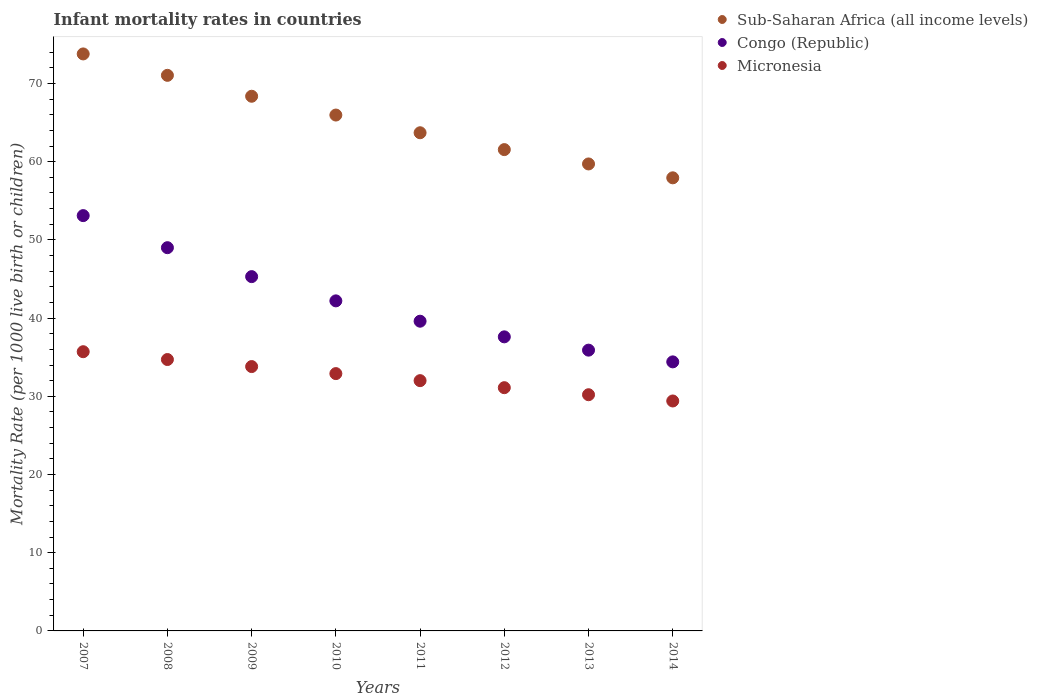Is the number of dotlines equal to the number of legend labels?
Make the answer very short. Yes. What is the infant mortality rate in Sub-Saharan Africa (all income levels) in 2012?
Provide a succinct answer. 61.54. Across all years, what is the maximum infant mortality rate in Sub-Saharan Africa (all income levels)?
Provide a succinct answer. 73.77. Across all years, what is the minimum infant mortality rate in Congo (Republic)?
Ensure brevity in your answer.  34.4. In which year was the infant mortality rate in Sub-Saharan Africa (all income levels) maximum?
Give a very brief answer. 2007. In which year was the infant mortality rate in Congo (Republic) minimum?
Your response must be concise. 2014. What is the total infant mortality rate in Sub-Saharan Africa (all income levels) in the graph?
Ensure brevity in your answer.  522. What is the difference between the infant mortality rate in Sub-Saharan Africa (all income levels) in 2011 and that in 2014?
Give a very brief answer. 5.76. What is the difference between the infant mortality rate in Sub-Saharan Africa (all income levels) in 2013 and the infant mortality rate in Congo (Republic) in 2012?
Make the answer very short. 22.11. What is the average infant mortality rate in Sub-Saharan Africa (all income levels) per year?
Offer a very short reply. 65.25. In the year 2009, what is the difference between the infant mortality rate in Sub-Saharan Africa (all income levels) and infant mortality rate in Micronesia?
Provide a short and direct response. 34.56. What is the ratio of the infant mortality rate in Sub-Saharan Africa (all income levels) in 2009 to that in 2014?
Make the answer very short. 1.18. Is the difference between the infant mortality rate in Sub-Saharan Africa (all income levels) in 2010 and 2013 greater than the difference between the infant mortality rate in Micronesia in 2010 and 2013?
Your answer should be compact. Yes. What is the difference between the highest and the second highest infant mortality rate in Micronesia?
Give a very brief answer. 1. What is the difference between the highest and the lowest infant mortality rate in Congo (Republic)?
Your answer should be very brief. 18.7. How many dotlines are there?
Offer a terse response. 3. Are the values on the major ticks of Y-axis written in scientific E-notation?
Provide a succinct answer. No. How are the legend labels stacked?
Your answer should be compact. Vertical. What is the title of the graph?
Your answer should be very brief. Infant mortality rates in countries. What is the label or title of the Y-axis?
Your response must be concise. Mortality Rate (per 1000 live birth or children). What is the Mortality Rate (per 1000 live birth or children) in Sub-Saharan Africa (all income levels) in 2007?
Your answer should be compact. 73.77. What is the Mortality Rate (per 1000 live birth or children) of Congo (Republic) in 2007?
Your answer should be compact. 53.1. What is the Mortality Rate (per 1000 live birth or children) of Micronesia in 2007?
Provide a short and direct response. 35.7. What is the Mortality Rate (per 1000 live birth or children) in Sub-Saharan Africa (all income levels) in 2008?
Keep it short and to the point. 71.04. What is the Mortality Rate (per 1000 live birth or children) in Micronesia in 2008?
Provide a succinct answer. 34.7. What is the Mortality Rate (per 1000 live birth or children) in Sub-Saharan Africa (all income levels) in 2009?
Offer a terse response. 68.36. What is the Mortality Rate (per 1000 live birth or children) in Congo (Republic) in 2009?
Your answer should be very brief. 45.3. What is the Mortality Rate (per 1000 live birth or children) of Micronesia in 2009?
Keep it short and to the point. 33.8. What is the Mortality Rate (per 1000 live birth or children) in Sub-Saharan Africa (all income levels) in 2010?
Offer a terse response. 65.96. What is the Mortality Rate (per 1000 live birth or children) of Congo (Republic) in 2010?
Keep it short and to the point. 42.2. What is the Mortality Rate (per 1000 live birth or children) in Micronesia in 2010?
Your response must be concise. 32.9. What is the Mortality Rate (per 1000 live birth or children) in Sub-Saharan Africa (all income levels) in 2011?
Your answer should be very brief. 63.7. What is the Mortality Rate (per 1000 live birth or children) in Congo (Republic) in 2011?
Provide a succinct answer. 39.6. What is the Mortality Rate (per 1000 live birth or children) in Micronesia in 2011?
Ensure brevity in your answer.  32. What is the Mortality Rate (per 1000 live birth or children) in Sub-Saharan Africa (all income levels) in 2012?
Your answer should be compact. 61.54. What is the Mortality Rate (per 1000 live birth or children) of Congo (Republic) in 2012?
Provide a succinct answer. 37.6. What is the Mortality Rate (per 1000 live birth or children) in Micronesia in 2012?
Ensure brevity in your answer.  31.1. What is the Mortality Rate (per 1000 live birth or children) of Sub-Saharan Africa (all income levels) in 2013?
Your answer should be compact. 59.71. What is the Mortality Rate (per 1000 live birth or children) in Congo (Republic) in 2013?
Your answer should be very brief. 35.9. What is the Mortality Rate (per 1000 live birth or children) of Micronesia in 2013?
Your answer should be compact. 30.2. What is the Mortality Rate (per 1000 live birth or children) of Sub-Saharan Africa (all income levels) in 2014?
Make the answer very short. 57.93. What is the Mortality Rate (per 1000 live birth or children) in Congo (Republic) in 2014?
Make the answer very short. 34.4. What is the Mortality Rate (per 1000 live birth or children) of Micronesia in 2014?
Your response must be concise. 29.4. Across all years, what is the maximum Mortality Rate (per 1000 live birth or children) in Sub-Saharan Africa (all income levels)?
Offer a terse response. 73.77. Across all years, what is the maximum Mortality Rate (per 1000 live birth or children) in Congo (Republic)?
Your answer should be very brief. 53.1. Across all years, what is the maximum Mortality Rate (per 1000 live birth or children) in Micronesia?
Provide a succinct answer. 35.7. Across all years, what is the minimum Mortality Rate (per 1000 live birth or children) in Sub-Saharan Africa (all income levels)?
Your answer should be compact. 57.93. Across all years, what is the minimum Mortality Rate (per 1000 live birth or children) in Congo (Republic)?
Your answer should be compact. 34.4. Across all years, what is the minimum Mortality Rate (per 1000 live birth or children) of Micronesia?
Your response must be concise. 29.4. What is the total Mortality Rate (per 1000 live birth or children) of Sub-Saharan Africa (all income levels) in the graph?
Keep it short and to the point. 522. What is the total Mortality Rate (per 1000 live birth or children) in Congo (Republic) in the graph?
Your answer should be compact. 337.1. What is the total Mortality Rate (per 1000 live birth or children) of Micronesia in the graph?
Offer a terse response. 259.8. What is the difference between the Mortality Rate (per 1000 live birth or children) of Sub-Saharan Africa (all income levels) in 2007 and that in 2008?
Provide a short and direct response. 2.74. What is the difference between the Mortality Rate (per 1000 live birth or children) of Sub-Saharan Africa (all income levels) in 2007 and that in 2009?
Provide a succinct answer. 5.41. What is the difference between the Mortality Rate (per 1000 live birth or children) in Congo (Republic) in 2007 and that in 2009?
Ensure brevity in your answer.  7.8. What is the difference between the Mortality Rate (per 1000 live birth or children) of Sub-Saharan Africa (all income levels) in 2007 and that in 2010?
Ensure brevity in your answer.  7.81. What is the difference between the Mortality Rate (per 1000 live birth or children) in Congo (Republic) in 2007 and that in 2010?
Provide a succinct answer. 10.9. What is the difference between the Mortality Rate (per 1000 live birth or children) of Sub-Saharan Africa (all income levels) in 2007 and that in 2011?
Provide a short and direct response. 10.08. What is the difference between the Mortality Rate (per 1000 live birth or children) of Congo (Republic) in 2007 and that in 2011?
Ensure brevity in your answer.  13.5. What is the difference between the Mortality Rate (per 1000 live birth or children) in Sub-Saharan Africa (all income levels) in 2007 and that in 2012?
Your answer should be very brief. 12.23. What is the difference between the Mortality Rate (per 1000 live birth or children) in Congo (Republic) in 2007 and that in 2012?
Your response must be concise. 15.5. What is the difference between the Mortality Rate (per 1000 live birth or children) of Sub-Saharan Africa (all income levels) in 2007 and that in 2013?
Provide a succinct answer. 14.07. What is the difference between the Mortality Rate (per 1000 live birth or children) in Congo (Republic) in 2007 and that in 2013?
Keep it short and to the point. 17.2. What is the difference between the Mortality Rate (per 1000 live birth or children) of Sub-Saharan Africa (all income levels) in 2007 and that in 2014?
Your answer should be very brief. 15.84. What is the difference between the Mortality Rate (per 1000 live birth or children) in Sub-Saharan Africa (all income levels) in 2008 and that in 2009?
Your response must be concise. 2.67. What is the difference between the Mortality Rate (per 1000 live birth or children) in Congo (Republic) in 2008 and that in 2009?
Give a very brief answer. 3.7. What is the difference between the Mortality Rate (per 1000 live birth or children) of Sub-Saharan Africa (all income levels) in 2008 and that in 2010?
Provide a succinct answer. 5.08. What is the difference between the Mortality Rate (per 1000 live birth or children) in Congo (Republic) in 2008 and that in 2010?
Provide a short and direct response. 6.8. What is the difference between the Mortality Rate (per 1000 live birth or children) in Micronesia in 2008 and that in 2010?
Your answer should be compact. 1.8. What is the difference between the Mortality Rate (per 1000 live birth or children) in Sub-Saharan Africa (all income levels) in 2008 and that in 2011?
Give a very brief answer. 7.34. What is the difference between the Mortality Rate (per 1000 live birth or children) in Congo (Republic) in 2008 and that in 2011?
Your answer should be compact. 9.4. What is the difference between the Mortality Rate (per 1000 live birth or children) in Sub-Saharan Africa (all income levels) in 2008 and that in 2012?
Make the answer very short. 9.5. What is the difference between the Mortality Rate (per 1000 live birth or children) in Sub-Saharan Africa (all income levels) in 2008 and that in 2013?
Provide a succinct answer. 11.33. What is the difference between the Mortality Rate (per 1000 live birth or children) of Micronesia in 2008 and that in 2013?
Your answer should be compact. 4.5. What is the difference between the Mortality Rate (per 1000 live birth or children) in Sub-Saharan Africa (all income levels) in 2008 and that in 2014?
Offer a terse response. 13.1. What is the difference between the Mortality Rate (per 1000 live birth or children) of Micronesia in 2008 and that in 2014?
Your response must be concise. 5.3. What is the difference between the Mortality Rate (per 1000 live birth or children) in Sub-Saharan Africa (all income levels) in 2009 and that in 2010?
Give a very brief answer. 2.4. What is the difference between the Mortality Rate (per 1000 live birth or children) in Congo (Republic) in 2009 and that in 2010?
Your answer should be compact. 3.1. What is the difference between the Mortality Rate (per 1000 live birth or children) in Sub-Saharan Africa (all income levels) in 2009 and that in 2011?
Offer a terse response. 4.67. What is the difference between the Mortality Rate (per 1000 live birth or children) in Congo (Republic) in 2009 and that in 2011?
Offer a very short reply. 5.7. What is the difference between the Mortality Rate (per 1000 live birth or children) in Micronesia in 2009 and that in 2011?
Offer a terse response. 1.8. What is the difference between the Mortality Rate (per 1000 live birth or children) of Sub-Saharan Africa (all income levels) in 2009 and that in 2012?
Ensure brevity in your answer.  6.82. What is the difference between the Mortality Rate (per 1000 live birth or children) in Congo (Republic) in 2009 and that in 2012?
Provide a succinct answer. 7.7. What is the difference between the Mortality Rate (per 1000 live birth or children) of Sub-Saharan Africa (all income levels) in 2009 and that in 2013?
Offer a very short reply. 8.65. What is the difference between the Mortality Rate (per 1000 live birth or children) in Congo (Republic) in 2009 and that in 2013?
Give a very brief answer. 9.4. What is the difference between the Mortality Rate (per 1000 live birth or children) in Micronesia in 2009 and that in 2013?
Give a very brief answer. 3.6. What is the difference between the Mortality Rate (per 1000 live birth or children) of Sub-Saharan Africa (all income levels) in 2009 and that in 2014?
Your answer should be compact. 10.43. What is the difference between the Mortality Rate (per 1000 live birth or children) in Congo (Republic) in 2009 and that in 2014?
Your response must be concise. 10.9. What is the difference between the Mortality Rate (per 1000 live birth or children) in Sub-Saharan Africa (all income levels) in 2010 and that in 2011?
Offer a terse response. 2.26. What is the difference between the Mortality Rate (per 1000 live birth or children) of Congo (Republic) in 2010 and that in 2011?
Offer a terse response. 2.6. What is the difference between the Mortality Rate (per 1000 live birth or children) of Sub-Saharan Africa (all income levels) in 2010 and that in 2012?
Provide a short and direct response. 4.42. What is the difference between the Mortality Rate (per 1000 live birth or children) of Micronesia in 2010 and that in 2012?
Your answer should be compact. 1.8. What is the difference between the Mortality Rate (per 1000 live birth or children) of Sub-Saharan Africa (all income levels) in 2010 and that in 2013?
Offer a very short reply. 6.25. What is the difference between the Mortality Rate (per 1000 live birth or children) in Micronesia in 2010 and that in 2013?
Provide a succinct answer. 2.7. What is the difference between the Mortality Rate (per 1000 live birth or children) in Sub-Saharan Africa (all income levels) in 2010 and that in 2014?
Provide a succinct answer. 8.03. What is the difference between the Mortality Rate (per 1000 live birth or children) of Sub-Saharan Africa (all income levels) in 2011 and that in 2012?
Ensure brevity in your answer.  2.15. What is the difference between the Mortality Rate (per 1000 live birth or children) in Congo (Republic) in 2011 and that in 2012?
Give a very brief answer. 2. What is the difference between the Mortality Rate (per 1000 live birth or children) in Micronesia in 2011 and that in 2012?
Ensure brevity in your answer.  0.9. What is the difference between the Mortality Rate (per 1000 live birth or children) in Sub-Saharan Africa (all income levels) in 2011 and that in 2013?
Keep it short and to the point. 3.99. What is the difference between the Mortality Rate (per 1000 live birth or children) of Sub-Saharan Africa (all income levels) in 2011 and that in 2014?
Offer a very short reply. 5.76. What is the difference between the Mortality Rate (per 1000 live birth or children) of Micronesia in 2011 and that in 2014?
Your answer should be compact. 2.6. What is the difference between the Mortality Rate (per 1000 live birth or children) in Sub-Saharan Africa (all income levels) in 2012 and that in 2013?
Provide a short and direct response. 1.83. What is the difference between the Mortality Rate (per 1000 live birth or children) of Congo (Republic) in 2012 and that in 2013?
Keep it short and to the point. 1.7. What is the difference between the Mortality Rate (per 1000 live birth or children) of Sub-Saharan Africa (all income levels) in 2012 and that in 2014?
Your response must be concise. 3.61. What is the difference between the Mortality Rate (per 1000 live birth or children) in Micronesia in 2012 and that in 2014?
Make the answer very short. 1.7. What is the difference between the Mortality Rate (per 1000 live birth or children) in Sub-Saharan Africa (all income levels) in 2013 and that in 2014?
Your answer should be very brief. 1.77. What is the difference between the Mortality Rate (per 1000 live birth or children) of Congo (Republic) in 2013 and that in 2014?
Your response must be concise. 1.5. What is the difference between the Mortality Rate (per 1000 live birth or children) of Sub-Saharan Africa (all income levels) in 2007 and the Mortality Rate (per 1000 live birth or children) of Congo (Republic) in 2008?
Your answer should be very brief. 24.77. What is the difference between the Mortality Rate (per 1000 live birth or children) of Sub-Saharan Africa (all income levels) in 2007 and the Mortality Rate (per 1000 live birth or children) of Micronesia in 2008?
Make the answer very short. 39.07. What is the difference between the Mortality Rate (per 1000 live birth or children) in Sub-Saharan Africa (all income levels) in 2007 and the Mortality Rate (per 1000 live birth or children) in Congo (Republic) in 2009?
Your response must be concise. 28.47. What is the difference between the Mortality Rate (per 1000 live birth or children) of Sub-Saharan Africa (all income levels) in 2007 and the Mortality Rate (per 1000 live birth or children) of Micronesia in 2009?
Offer a terse response. 39.97. What is the difference between the Mortality Rate (per 1000 live birth or children) of Congo (Republic) in 2007 and the Mortality Rate (per 1000 live birth or children) of Micronesia in 2009?
Provide a short and direct response. 19.3. What is the difference between the Mortality Rate (per 1000 live birth or children) in Sub-Saharan Africa (all income levels) in 2007 and the Mortality Rate (per 1000 live birth or children) in Congo (Republic) in 2010?
Provide a short and direct response. 31.57. What is the difference between the Mortality Rate (per 1000 live birth or children) in Sub-Saharan Africa (all income levels) in 2007 and the Mortality Rate (per 1000 live birth or children) in Micronesia in 2010?
Keep it short and to the point. 40.87. What is the difference between the Mortality Rate (per 1000 live birth or children) in Congo (Republic) in 2007 and the Mortality Rate (per 1000 live birth or children) in Micronesia in 2010?
Provide a succinct answer. 20.2. What is the difference between the Mortality Rate (per 1000 live birth or children) of Sub-Saharan Africa (all income levels) in 2007 and the Mortality Rate (per 1000 live birth or children) of Congo (Republic) in 2011?
Keep it short and to the point. 34.17. What is the difference between the Mortality Rate (per 1000 live birth or children) in Sub-Saharan Africa (all income levels) in 2007 and the Mortality Rate (per 1000 live birth or children) in Micronesia in 2011?
Offer a very short reply. 41.77. What is the difference between the Mortality Rate (per 1000 live birth or children) in Congo (Republic) in 2007 and the Mortality Rate (per 1000 live birth or children) in Micronesia in 2011?
Your answer should be very brief. 21.1. What is the difference between the Mortality Rate (per 1000 live birth or children) in Sub-Saharan Africa (all income levels) in 2007 and the Mortality Rate (per 1000 live birth or children) in Congo (Republic) in 2012?
Offer a very short reply. 36.17. What is the difference between the Mortality Rate (per 1000 live birth or children) of Sub-Saharan Africa (all income levels) in 2007 and the Mortality Rate (per 1000 live birth or children) of Micronesia in 2012?
Make the answer very short. 42.67. What is the difference between the Mortality Rate (per 1000 live birth or children) in Sub-Saharan Africa (all income levels) in 2007 and the Mortality Rate (per 1000 live birth or children) in Congo (Republic) in 2013?
Offer a very short reply. 37.87. What is the difference between the Mortality Rate (per 1000 live birth or children) in Sub-Saharan Africa (all income levels) in 2007 and the Mortality Rate (per 1000 live birth or children) in Micronesia in 2013?
Give a very brief answer. 43.57. What is the difference between the Mortality Rate (per 1000 live birth or children) of Congo (Republic) in 2007 and the Mortality Rate (per 1000 live birth or children) of Micronesia in 2013?
Provide a short and direct response. 22.9. What is the difference between the Mortality Rate (per 1000 live birth or children) of Sub-Saharan Africa (all income levels) in 2007 and the Mortality Rate (per 1000 live birth or children) of Congo (Republic) in 2014?
Offer a terse response. 39.37. What is the difference between the Mortality Rate (per 1000 live birth or children) of Sub-Saharan Africa (all income levels) in 2007 and the Mortality Rate (per 1000 live birth or children) of Micronesia in 2014?
Provide a short and direct response. 44.37. What is the difference between the Mortality Rate (per 1000 live birth or children) in Congo (Republic) in 2007 and the Mortality Rate (per 1000 live birth or children) in Micronesia in 2014?
Keep it short and to the point. 23.7. What is the difference between the Mortality Rate (per 1000 live birth or children) of Sub-Saharan Africa (all income levels) in 2008 and the Mortality Rate (per 1000 live birth or children) of Congo (Republic) in 2009?
Keep it short and to the point. 25.74. What is the difference between the Mortality Rate (per 1000 live birth or children) of Sub-Saharan Africa (all income levels) in 2008 and the Mortality Rate (per 1000 live birth or children) of Micronesia in 2009?
Your answer should be very brief. 37.24. What is the difference between the Mortality Rate (per 1000 live birth or children) of Sub-Saharan Africa (all income levels) in 2008 and the Mortality Rate (per 1000 live birth or children) of Congo (Republic) in 2010?
Your answer should be very brief. 28.84. What is the difference between the Mortality Rate (per 1000 live birth or children) in Sub-Saharan Africa (all income levels) in 2008 and the Mortality Rate (per 1000 live birth or children) in Micronesia in 2010?
Provide a succinct answer. 38.14. What is the difference between the Mortality Rate (per 1000 live birth or children) of Sub-Saharan Africa (all income levels) in 2008 and the Mortality Rate (per 1000 live birth or children) of Congo (Republic) in 2011?
Ensure brevity in your answer.  31.44. What is the difference between the Mortality Rate (per 1000 live birth or children) in Sub-Saharan Africa (all income levels) in 2008 and the Mortality Rate (per 1000 live birth or children) in Micronesia in 2011?
Your response must be concise. 39.04. What is the difference between the Mortality Rate (per 1000 live birth or children) of Congo (Republic) in 2008 and the Mortality Rate (per 1000 live birth or children) of Micronesia in 2011?
Your answer should be very brief. 17. What is the difference between the Mortality Rate (per 1000 live birth or children) in Sub-Saharan Africa (all income levels) in 2008 and the Mortality Rate (per 1000 live birth or children) in Congo (Republic) in 2012?
Your answer should be very brief. 33.44. What is the difference between the Mortality Rate (per 1000 live birth or children) in Sub-Saharan Africa (all income levels) in 2008 and the Mortality Rate (per 1000 live birth or children) in Micronesia in 2012?
Offer a terse response. 39.94. What is the difference between the Mortality Rate (per 1000 live birth or children) of Congo (Republic) in 2008 and the Mortality Rate (per 1000 live birth or children) of Micronesia in 2012?
Make the answer very short. 17.9. What is the difference between the Mortality Rate (per 1000 live birth or children) in Sub-Saharan Africa (all income levels) in 2008 and the Mortality Rate (per 1000 live birth or children) in Congo (Republic) in 2013?
Offer a terse response. 35.14. What is the difference between the Mortality Rate (per 1000 live birth or children) of Sub-Saharan Africa (all income levels) in 2008 and the Mortality Rate (per 1000 live birth or children) of Micronesia in 2013?
Ensure brevity in your answer.  40.84. What is the difference between the Mortality Rate (per 1000 live birth or children) in Congo (Republic) in 2008 and the Mortality Rate (per 1000 live birth or children) in Micronesia in 2013?
Provide a short and direct response. 18.8. What is the difference between the Mortality Rate (per 1000 live birth or children) in Sub-Saharan Africa (all income levels) in 2008 and the Mortality Rate (per 1000 live birth or children) in Congo (Republic) in 2014?
Provide a succinct answer. 36.64. What is the difference between the Mortality Rate (per 1000 live birth or children) in Sub-Saharan Africa (all income levels) in 2008 and the Mortality Rate (per 1000 live birth or children) in Micronesia in 2014?
Your answer should be compact. 41.64. What is the difference between the Mortality Rate (per 1000 live birth or children) in Congo (Republic) in 2008 and the Mortality Rate (per 1000 live birth or children) in Micronesia in 2014?
Your answer should be compact. 19.6. What is the difference between the Mortality Rate (per 1000 live birth or children) of Sub-Saharan Africa (all income levels) in 2009 and the Mortality Rate (per 1000 live birth or children) of Congo (Republic) in 2010?
Give a very brief answer. 26.16. What is the difference between the Mortality Rate (per 1000 live birth or children) in Sub-Saharan Africa (all income levels) in 2009 and the Mortality Rate (per 1000 live birth or children) in Micronesia in 2010?
Keep it short and to the point. 35.46. What is the difference between the Mortality Rate (per 1000 live birth or children) in Sub-Saharan Africa (all income levels) in 2009 and the Mortality Rate (per 1000 live birth or children) in Congo (Republic) in 2011?
Offer a very short reply. 28.76. What is the difference between the Mortality Rate (per 1000 live birth or children) in Sub-Saharan Africa (all income levels) in 2009 and the Mortality Rate (per 1000 live birth or children) in Micronesia in 2011?
Your response must be concise. 36.36. What is the difference between the Mortality Rate (per 1000 live birth or children) of Sub-Saharan Africa (all income levels) in 2009 and the Mortality Rate (per 1000 live birth or children) of Congo (Republic) in 2012?
Your answer should be very brief. 30.76. What is the difference between the Mortality Rate (per 1000 live birth or children) in Sub-Saharan Africa (all income levels) in 2009 and the Mortality Rate (per 1000 live birth or children) in Micronesia in 2012?
Ensure brevity in your answer.  37.26. What is the difference between the Mortality Rate (per 1000 live birth or children) in Congo (Republic) in 2009 and the Mortality Rate (per 1000 live birth or children) in Micronesia in 2012?
Offer a very short reply. 14.2. What is the difference between the Mortality Rate (per 1000 live birth or children) in Sub-Saharan Africa (all income levels) in 2009 and the Mortality Rate (per 1000 live birth or children) in Congo (Republic) in 2013?
Your answer should be compact. 32.46. What is the difference between the Mortality Rate (per 1000 live birth or children) in Sub-Saharan Africa (all income levels) in 2009 and the Mortality Rate (per 1000 live birth or children) in Micronesia in 2013?
Ensure brevity in your answer.  38.16. What is the difference between the Mortality Rate (per 1000 live birth or children) in Sub-Saharan Africa (all income levels) in 2009 and the Mortality Rate (per 1000 live birth or children) in Congo (Republic) in 2014?
Offer a terse response. 33.96. What is the difference between the Mortality Rate (per 1000 live birth or children) of Sub-Saharan Africa (all income levels) in 2009 and the Mortality Rate (per 1000 live birth or children) of Micronesia in 2014?
Give a very brief answer. 38.96. What is the difference between the Mortality Rate (per 1000 live birth or children) of Congo (Republic) in 2009 and the Mortality Rate (per 1000 live birth or children) of Micronesia in 2014?
Your answer should be compact. 15.9. What is the difference between the Mortality Rate (per 1000 live birth or children) in Sub-Saharan Africa (all income levels) in 2010 and the Mortality Rate (per 1000 live birth or children) in Congo (Republic) in 2011?
Give a very brief answer. 26.36. What is the difference between the Mortality Rate (per 1000 live birth or children) of Sub-Saharan Africa (all income levels) in 2010 and the Mortality Rate (per 1000 live birth or children) of Micronesia in 2011?
Your response must be concise. 33.96. What is the difference between the Mortality Rate (per 1000 live birth or children) in Sub-Saharan Africa (all income levels) in 2010 and the Mortality Rate (per 1000 live birth or children) in Congo (Republic) in 2012?
Ensure brevity in your answer.  28.36. What is the difference between the Mortality Rate (per 1000 live birth or children) of Sub-Saharan Africa (all income levels) in 2010 and the Mortality Rate (per 1000 live birth or children) of Micronesia in 2012?
Provide a succinct answer. 34.86. What is the difference between the Mortality Rate (per 1000 live birth or children) in Congo (Republic) in 2010 and the Mortality Rate (per 1000 live birth or children) in Micronesia in 2012?
Offer a terse response. 11.1. What is the difference between the Mortality Rate (per 1000 live birth or children) of Sub-Saharan Africa (all income levels) in 2010 and the Mortality Rate (per 1000 live birth or children) of Congo (Republic) in 2013?
Offer a terse response. 30.06. What is the difference between the Mortality Rate (per 1000 live birth or children) of Sub-Saharan Africa (all income levels) in 2010 and the Mortality Rate (per 1000 live birth or children) of Micronesia in 2013?
Offer a very short reply. 35.76. What is the difference between the Mortality Rate (per 1000 live birth or children) in Congo (Republic) in 2010 and the Mortality Rate (per 1000 live birth or children) in Micronesia in 2013?
Offer a terse response. 12. What is the difference between the Mortality Rate (per 1000 live birth or children) in Sub-Saharan Africa (all income levels) in 2010 and the Mortality Rate (per 1000 live birth or children) in Congo (Republic) in 2014?
Make the answer very short. 31.56. What is the difference between the Mortality Rate (per 1000 live birth or children) of Sub-Saharan Africa (all income levels) in 2010 and the Mortality Rate (per 1000 live birth or children) of Micronesia in 2014?
Give a very brief answer. 36.56. What is the difference between the Mortality Rate (per 1000 live birth or children) in Sub-Saharan Africa (all income levels) in 2011 and the Mortality Rate (per 1000 live birth or children) in Congo (Republic) in 2012?
Make the answer very short. 26.1. What is the difference between the Mortality Rate (per 1000 live birth or children) in Sub-Saharan Africa (all income levels) in 2011 and the Mortality Rate (per 1000 live birth or children) in Micronesia in 2012?
Your answer should be compact. 32.6. What is the difference between the Mortality Rate (per 1000 live birth or children) in Sub-Saharan Africa (all income levels) in 2011 and the Mortality Rate (per 1000 live birth or children) in Congo (Republic) in 2013?
Make the answer very short. 27.8. What is the difference between the Mortality Rate (per 1000 live birth or children) in Sub-Saharan Africa (all income levels) in 2011 and the Mortality Rate (per 1000 live birth or children) in Micronesia in 2013?
Ensure brevity in your answer.  33.5. What is the difference between the Mortality Rate (per 1000 live birth or children) of Sub-Saharan Africa (all income levels) in 2011 and the Mortality Rate (per 1000 live birth or children) of Congo (Republic) in 2014?
Provide a succinct answer. 29.3. What is the difference between the Mortality Rate (per 1000 live birth or children) in Sub-Saharan Africa (all income levels) in 2011 and the Mortality Rate (per 1000 live birth or children) in Micronesia in 2014?
Offer a terse response. 34.3. What is the difference between the Mortality Rate (per 1000 live birth or children) of Sub-Saharan Africa (all income levels) in 2012 and the Mortality Rate (per 1000 live birth or children) of Congo (Republic) in 2013?
Your answer should be very brief. 25.64. What is the difference between the Mortality Rate (per 1000 live birth or children) in Sub-Saharan Africa (all income levels) in 2012 and the Mortality Rate (per 1000 live birth or children) in Micronesia in 2013?
Offer a very short reply. 31.34. What is the difference between the Mortality Rate (per 1000 live birth or children) in Sub-Saharan Africa (all income levels) in 2012 and the Mortality Rate (per 1000 live birth or children) in Congo (Republic) in 2014?
Your response must be concise. 27.14. What is the difference between the Mortality Rate (per 1000 live birth or children) in Sub-Saharan Africa (all income levels) in 2012 and the Mortality Rate (per 1000 live birth or children) in Micronesia in 2014?
Your answer should be very brief. 32.14. What is the difference between the Mortality Rate (per 1000 live birth or children) of Congo (Republic) in 2012 and the Mortality Rate (per 1000 live birth or children) of Micronesia in 2014?
Your answer should be very brief. 8.2. What is the difference between the Mortality Rate (per 1000 live birth or children) of Sub-Saharan Africa (all income levels) in 2013 and the Mortality Rate (per 1000 live birth or children) of Congo (Republic) in 2014?
Give a very brief answer. 25.31. What is the difference between the Mortality Rate (per 1000 live birth or children) in Sub-Saharan Africa (all income levels) in 2013 and the Mortality Rate (per 1000 live birth or children) in Micronesia in 2014?
Give a very brief answer. 30.31. What is the average Mortality Rate (per 1000 live birth or children) in Sub-Saharan Africa (all income levels) per year?
Ensure brevity in your answer.  65.25. What is the average Mortality Rate (per 1000 live birth or children) of Congo (Republic) per year?
Give a very brief answer. 42.14. What is the average Mortality Rate (per 1000 live birth or children) of Micronesia per year?
Make the answer very short. 32.48. In the year 2007, what is the difference between the Mortality Rate (per 1000 live birth or children) of Sub-Saharan Africa (all income levels) and Mortality Rate (per 1000 live birth or children) of Congo (Republic)?
Provide a short and direct response. 20.67. In the year 2007, what is the difference between the Mortality Rate (per 1000 live birth or children) of Sub-Saharan Africa (all income levels) and Mortality Rate (per 1000 live birth or children) of Micronesia?
Provide a short and direct response. 38.07. In the year 2007, what is the difference between the Mortality Rate (per 1000 live birth or children) of Congo (Republic) and Mortality Rate (per 1000 live birth or children) of Micronesia?
Give a very brief answer. 17.4. In the year 2008, what is the difference between the Mortality Rate (per 1000 live birth or children) of Sub-Saharan Africa (all income levels) and Mortality Rate (per 1000 live birth or children) of Congo (Republic)?
Keep it short and to the point. 22.04. In the year 2008, what is the difference between the Mortality Rate (per 1000 live birth or children) in Sub-Saharan Africa (all income levels) and Mortality Rate (per 1000 live birth or children) in Micronesia?
Ensure brevity in your answer.  36.34. In the year 2009, what is the difference between the Mortality Rate (per 1000 live birth or children) in Sub-Saharan Africa (all income levels) and Mortality Rate (per 1000 live birth or children) in Congo (Republic)?
Offer a very short reply. 23.06. In the year 2009, what is the difference between the Mortality Rate (per 1000 live birth or children) of Sub-Saharan Africa (all income levels) and Mortality Rate (per 1000 live birth or children) of Micronesia?
Your answer should be compact. 34.56. In the year 2009, what is the difference between the Mortality Rate (per 1000 live birth or children) in Congo (Republic) and Mortality Rate (per 1000 live birth or children) in Micronesia?
Make the answer very short. 11.5. In the year 2010, what is the difference between the Mortality Rate (per 1000 live birth or children) in Sub-Saharan Africa (all income levels) and Mortality Rate (per 1000 live birth or children) in Congo (Republic)?
Ensure brevity in your answer.  23.76. In the year 2010, what is the difference between the Mortality Rate (per 1000 live birth or children) of Sub-Saharan Africa (all income levels) and Mortality Rate (per 1000 live birth or children) of Micronesia?
Provide a short and direct response. 33.06. In the year 2010, what is the difference between the Mortality Rate (per 1000 live birth or children) of Congo (Republic) and Mortality Rate (per 1000 live birth or children) of Micronesia?
Keep it short and to the point. 9.3. In the year 2011, what is the difference between the Mortality Rate (per 1000 live birth or children) of Sub-Saharan Africa (all income levels) and Mortality Rate (per 1000 live birth or children) of Congo (Republic)?
Keep it short and to the point. 24.1. In the year 2011, what is the difference between the Mortality Rate (per 1000 live birth or children) in Sub-Saharan Africa (all income levels) and Mortality Rate (per 1000 live birth or children) in Micronesia?
Provide a short and direct response. 31.7. In the year 2012, what is the difference between the Mortality Rate (per 1000 live birth or children) of Sub-Saharan Africa (all income levels) and Mortality Rate (per 1000 live birth or children) of Congo (Republic)?
Your answer should be compact. 23.94. In the year 2012, what is the difference between the Mortality Rate (per 1000 live birth or children) in Sub-Saharan Africa (all income levels) and Mortality Rate (per 1000 live birth or children) in Micronesia?
Provide a short and direct response. 30.44. In the year 2013, what is the difference between the Mortality Rate (per 1000 live birth or children) in Sub-Saharan Africa (all income levels) and Mortality Rate (per 1000 live birth or children) in Congo (Republic)?
Provide a short and direct response. 23.81. In the year 2013, what is the difference between the Mortality Rate (per 1000 live birth or children) of Sub-Saharan Africa (all income levels) and Mortality Rate (per 1000 live birth or children) of Micronesia?
Keep it short and to the point. 29.51. In the year 2013, what is the difference between the Mortality Rate (per 1000 live birth or children) in Congo (Republic) and Mortality Rate (per 1000 live birth or children) in Micronesia?
Keep it short and to the point. 5.7. In the year 2014, what is the difference between the Mortality Rate (per 1000 live birth or children) of Sub-Saharan Africa (all income levels) and Mortality Rate (per 1000 live birth or children) of Congo (Republic)?
Your answer should be compact. 23.53. In the year 2014, what is the difference between the Mortality Rate (per 1000 live birth or children) in Sub-Saharan Africa (all income levels) and Mortality Rate (per 1000 live birth or children) in Micronesia?
Ensure brevity in your answer.  28.53. In the year 2014, what is the difference between the Mortality Rate (per 1000 live birth or children) in Congo (Republic) and Mortality Rate (per 1000 live birth or children) in Micronesia?
Ensure brevity in your answer.  5. What is the ratio of the Mortality Rate (per 1000 live birth or children) in Congo (Republic) in 2007 to that in 2008?
Offer a terse response. 1.08. What is the ratio of the Mortality Rate (per 1000 live birth or children) in Micronesia in 2007 to that in 2008?
Your answer should be very brief. 1.03. What is the ratio of the Mortality Rate (per 1000 live birth or children) in Sub-Saharan Africa (all income levels) in 2007 to that in 2009?
Provide a short and direct response. 1.08. What is the ratio of the Mortality Rate (per 1000 live birth or children) in Congo (Republic) in 2007 to that in 2009?
Provide a succinct answer. 1.17. What is the ratio of the Mortality Rate (per 1000 live birth or children) of Micronesia in 2007 to that in 2009?
Offer a terse response. 1.06. What is the ratio of the Mortality Rate (per 1000 live birth or children) of Sub-Saharan Africa (all income levels) in 2007 to that in 2010?
Ensure brevity in your answer.  1.12. What is the ratio of the Mortality Rate (per 1000 live birth or children) of Congo (Republic) in 2007 to that in 2010?
Ensure brevity in your answer.  1.26. What is the ratio of the Mortality Rate (per 1000 live birth or children) in Micronesia in 2007 to that in 2010?
Your answer should be very brief. 1.09. What is the ratio of the Mortality Rate (per 1000 live birth or children) in Sub-Saharan Africa (all income levels) in 2007 to that in 2011?
Ensure brevity in your answer.  1.16. What is the ratio of the Mortality Rate (per 1000 live birth or children) of Congo (Republic) in 2007 to that in 2011?
Your answer should be very brief. 1.34. What is the ratio of the Mortality Rate (per 1000 live birth or children) in Micronesia in 2007 to that in 2011?
Give a very brief answer. 1.12. What is the ratio of the Mortality Rate (per 1000 live birth or children) of Sub-Saharan Africa (all income levels) in 2007 to that in 2012?
Offer a very short reply. 1.2. What is the ratio of the Mortality Rate (per 1000 live birth or children) of Congo (Republic) in 2007 to that in 2012?
Your response must be concise. 1.41. What is the ratio of the Mortality Rate (per 1000 live birth or children) in Micronesia in 2007 to that in 2012?
Keep it short and to the point. 1.15. What is the ratio of the Mortality Rate (per 1000 live birth or children) of Sub-Saharan Africa (all income levels) in 2007 to that in 2013?
Make the answer very short. 1.24. What is the ratio of the Mortality Rate (per 1000 live birth or children) in Congo (Republic) in 2007 to that in 2013?
Provide a short and direct response. 1.48. What is the ratio of the Mortality Rate (per 1000 live birth or children) in Micronesia in 2007 to that in 2013?
Give a very brief answer. 1.18. What is the ratio of the Mortality Rate (per 1000 live birth or children) of Sub-Saharan Africa (all income levels) in 2007 to that in 2014?
Provide a short and direct response. 1.27. What is the ratio of the Mortality Rate (per 1000 live birth or children) in Congo (Republic) in 2007 to that in 2014?
Provide a succinct answer. 1.54. What is the ratio of the Mortality Rate (per 1000 live birth or children) in Micronesia in 2007 to that in 2014?
Give a very brief answer. 1.21. What is the ratio of the Mortality Rate (per 1000 live birth or children) of Sub-Saharan Africa (all income levels) in 2008 to that in 2009?
Your response must be concise. 1.04. What is the ratio of the Mortality Rate (per 1000 live birth or children) in Congo (Republic) in 2008 to that in 2009?
Provide a short and direct response. 1.08. What is the ratio of the Mortality Rate (per 1000 live birth or children) of Micronesia in 2008 to that in 2009?
Make the answer very short. 1.03. What is the ratio of the Mortality Rate (per 1000 live birth or children) of Sub-Saharan Africa (all income levels) in 2008 to that in 2010?
Ensure brevity in your answer.  1.08. What is the ratio of the Mortality Rate (per 1000 live birth or children) of Congo (Republic) in 2008 to that in 2010?
Keep it short and to the point. 1.16. What is the ratio of the Mortality Rate (per 1000 live birth or children) of Micronesia in 2008 to that in 2010?
Keep it short and to the point. 1.05. What is the ratio of the Mortality Rate (per 1000 live birth or children) of Sub-Saharan Africa (all income levels) in 2008 to that in 2011?
Your answer should be very brief. 1.12. What is the ratio of the Mortality Rate (per 1000 live birth or children) in Congo (Republic) in 2008 to that in 2011?
Provide a succinct answer. 1.24. What is the ratio of the Mortality Rate (per 1000 live birth or children) in Micronesia in 2008 to that in 2011?
Your answer should be very brief. 1.08. What is the ratio of the Mortality Rate (per 1000 live birth or children) of Sub-Saharan Africa (all income levels) in 2008 to that in 2012?
Your answer should be very brief. 1.15. What is the ratio of the Mortality Rate (per 1000 live birth or children) in Congo (Republic) in 2008 to that in 2012?
Offer a very short reply. 1.3. What is the ratio of the Mortality Rate (per 1000 live birth or children) of Micronesia in 2008 to that in 2012?
Provide a short and direct response. 1.12. What is the ratio of the Mortality Rate (per 1000 live birth or children) of Sub-Saharan Africa (all income levels) in 2008 to that in 2013?
Keep it short and to the point. 1.19. What is the ratio of the Mortality Rate (per 1000 live birth or children) of Congo (Republic) in 2008 to that in 2013?
Keep it short and to the point. 1.36. What is the ratio of the Mortality Rate (per 1000 live birth or children) of Micronesia in 2008 to that in 2013?
Your answer should be compact. 1.15. What is the ratio of the Mortality Rate (per 1000 live birth or children) in Sub-Saharan Africa (all income levels) in 2008 to that in 2014?
Your answer should be compact. 1.23. What is the ratio of the Mortality Rate (per 1000 live birth or children) of Congo (Republic) in 2008 to that in 2014?
Keep it short and to the point. 1.42. What is the ratio of the Mortality Rate (per 1000 live birth or children) of Micronesia in 2008 to that in 2014?
Give a very brief answer. 1.18. What is the ratio of the Mortality Rate (per 1000 live birth or children) of Sub-Saharan Africa (all income levels) in 2009 to that in 2010?
Offer a terse response. 1.04. What is the ratio of the Mortality Rate (per 1000 live birth or children) of Congo (Republic) in 2009 to that in 2010?
Your response must be concise. 1.07. What is the ratio of the Mortality Rate (per 1000 live birth or children) in Micronesia in 2009 to that in 2010?
Your response must be concise. 1.03. What is the ratio of the Mortality Rate (per 1000 live birth or children) of Sub-Saharan Africa (all income levels) in 2009 to that in 2011?
Make the answer very short. 1.07. What is the ratio of the Mortality Rate (per 1000 live birth or children) in Congo (Republic) in 2009 to that in 2011?
Offer a very short reply. 1.14. What is the ratio of the Mortality Rate (per 1000 live birth or children) of Micronesia in 2009 to that in 2011?
Keep it short and to the point. 1.06. What is the ratio of the Mortality Rate (per 1000 live birth or children) in Sub-Saharan Africa (all income levels) in 2009 to that in 2012?
Your response must be concise. 1.11. What is the ratio of the Mortality Rate (per 1000 live birth or children) of Congo (Republic) in 2009 to that in 2012?
Offer a terse response. 1.2. What is the ratio of the Mortality Rate (per 1000 live birth or children) in Micronesia in 2009 to that in 2012?
Provide a succinct answer. 1.09. What is the ratio of the Mortality Rate (per 1000 live birth or children) of Sub-Saharan Africa (all income levels) in 2009 to that in 2013?
Your response must be concise. 1.15. What is the ratio of the Mortality Rate (per 1000 live birth or children) in Congo (Republic) in 2009 to that in 2013?
Make the answer very short. 1.26. What is the ratio of the Mortality Rate (per 1000 live birth or children) in Micronesia in 2009 to that in 2013?
Give a very brief answer. 1.12. What is the ratio of the Mortality Rate (per 1000 live birth or children) in Sub-Saharan Africa (all income levels) in 2009 to that in 2014?
Provide a succinct answer. 1.18. What is the ratio of the Mortality Rate (per 1000 live birth or children) of Congo (Republic) in 2009 to that in 2014?
Your response must be concise. 1.32. What is the ratio of the Mortality Rate (per 1000 live birth or children) in Micronesia in 2009 to that in 2014?
Your response must be concise. 1.15. What is the ratio of the Mortality Rate (per 1000 live birth or children) of Sub-Saharan Africa (all income levels) in 2010 to that in 2011?
Provide a short and direct response. 1.04. What is the ratio of the Mortality Rate (per 1000 live birth or children) in Congo (Republic) in 2010 to that in 2011?
Your answer should be compact. 1.07. What is the ratio of the Mortality Rate (per 1000 live birth or children) of Micronesia in 2010 to that in 2011?
Provide a short and direct response. 1.03. What is the ratio of the Mortality Rate (per 1000 live birth or children) of Sub-Saharan Africa (all income levels) in 2010 to that in 2012?
Offer a terse response. 1.07. What is the ratio of the Mortality Rate (per 1000 live birth or children) of Congo (Republic) in 2010 to that in 2012?
Your answer should be very brief. 1.12. What is the ratio of the Mortality Rate (per 1000 live birth or children) in Micronesia in 2010 to that in 2012?
Give a very brief answer. 1.06. What is the ratio of the Mortality Rate (per 1000 live birth or children) in Sub-Saharan Africa (all income levels) in 2010 to that in 2013?
Provide a short and direct response. 1.1. What is the ratio of the Mortality Rate (per 1000 live birth or children) in Congo (Republic) in 2010 to that in 2013?
Your answer should be very brief. 1.18. What is the ratio of the Mortality Rate (per 1000 live birth or children) of Micronesia in 2010 to that in 2013?
Give a very brief answer. 1.09. What is the ratio of the Mortality Rate (per 1000 live birth or children) of Sub-Saharan Africa (all income levels) in 2010 to that in 2014?
Provide a short and direct response. 1.14. What is the ratio of the Mortality Rate (per 1000 live birth or children) of Congo (Republic) in 2010 to that in 2014?
Provide a short and direct response. 1.23. What is the ratio of the Mortality Rate (per 1000 live birth or children) of Micronesia in 2010 to that in 2014?
Keep it short and to the point. 1.12. What is the ratio of the Mortality Rate (per 1000 live birth or children) of Sub-Saharan Africa (all income levels) in 2011 to that in 2012?
Offer a very short reply. 1.03. What is the ratio of the Mortality Rate (per 1000 live birth or children) of Congo (Republic) in 2011 to that in 2012?
Provide a short and direct response. 1.05. What is the ratio of the Mortality Rate (per 1000 live birth or children) in Micronesia in 2011 to that in 2012?
Keep it short and to the point. 1.03. What is the ratio of the Mortality Rate (per 1000 live birth or children) of Sub-Saharan Africa (all income levels) in 2011 to that in 2013?
Keep it short and to the point. 1.07. What is the ratio of the Mortality Rate (per 1000 live birth or children) in Congo (Republic) in 2011 to that in 2013?
Your answer should be compact. 1.1. What is the ratio of the Mortality Rate (per 1000 live birth or children) of Micronesia in 2011 to that in 2013?
Provide a short and direct response. 1.06. What is the ratio of the Mortality Rate (per 1000 live birth or children) of Sub-Saharan Africa (all income levels) in 2011 to that in 2014?
Ensure brevity in your answer.  1.1. What is the ratio of the Mortality Rate (per 1000 live birth or children) in Congo (Republic) in 2011 to that in 2014?
Provide a succinct answer. 1.15. What is the ratio of the Mortality Rate (per 1000 live birth or children) of Micronesia in 2011 to that in 2014?
Ensure brevity in your answer.  1.09. What is the ratio of the Mortality Rate (per 1000 live birth or children) in Sub-Saharan Africa (all income levels) in 2012 to that in 2013?
Offer a terse response. 1.03. What is the ratio of the Mortality Rate (per 1000 live birth or children) of Congo (Republic) in 2012 to that in 2013?
Give a very brief answer. 1.05. What is the ratio of the Mortality Rate (per 1000 live birth or children) in Micronesia in 2012 to that in 2013?
Your response must be concise. 1.03. What is the ratio of the Mortality Rate (per 1000 live birth or children) of Sub-Saharan Africa (all income levels) in 2012 to that in 2014?
Give a very brief answer. 1.06. What is the ratio of the Mortality Rate (per 1000 live birth or children) in Congo (Republic) in 2012 to that in 2014?
Ensure brevity in your answer.  1.09. What is the ratio of the Mortality Rate (per 1000 live birth or children) in Micronesia in 2012 to that in 2014?
Make the answer very short. 1.06. What is the ratio of the Mortality Rate (per 1000 live birth or children) in Sub-Saharan Africa (all income levels) in 2013 to that in 2014?
Offer a very short reply. 1.03. What is the ratio of the Mortality Rate (per 1000 live birth or children) of Congo (Republic) in 2013 to that in 2014?
Give a very brief answer. 1.04. What is the ratio of the Mortality Rate (per 1000 live birth or children) in Micronesia in 2013 to that in 2014?
Keep it short and to the point. 1.03. What is the difference between the highest and the second highest Mortality Rate (per 1000 live birth or children) of Sub-Saharan Africa (all income levels)?
Offer a very short reply. 2.74. What is the difference between the highest and the second highest Mortality Rate (per 1000 live birth or children) in Congo (Republic)?
Your answer should be very brief. 4.1. What is the difference between the highest and the second highest Mortality Rate (per 1000 live birth or children) in Micronesia?
Your answer should be compact. 1. What is the difference between the highest and the lowest Mortality Rate (per 1000 live birth or children) of Sub-Saharan Africa (all income levels)?
Provide a short and direct response. 15.84. What is the difference between the highest and the lowest Mortality Rate (per 1000 live birth or children) in Micronesia?
Offer a terse response. 6.3. 